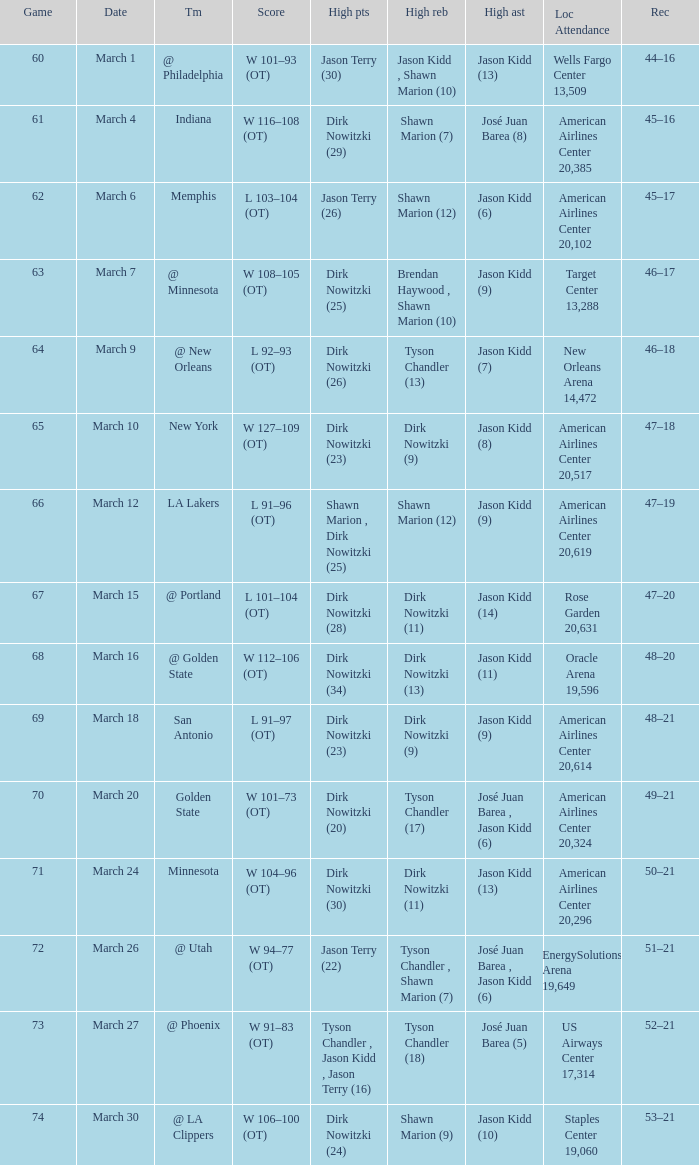Name the high points for march 30 Dirk Nowitzki (24). 